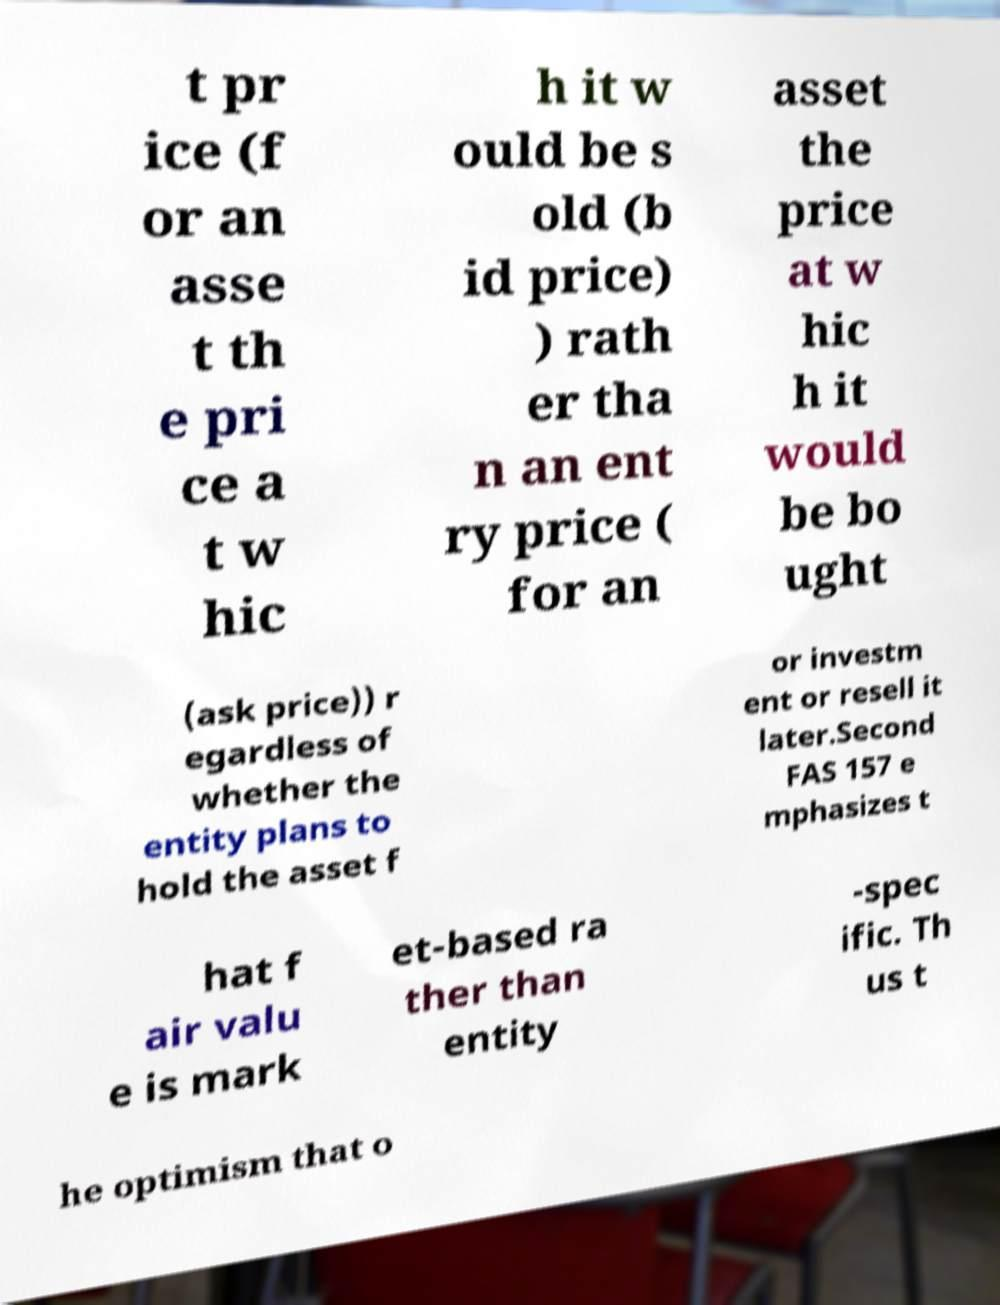I need the written content from this picture converted into text. Can you do that? t pr ice (f or an asse t th e pri ce a t w hic h it w ould be s old (b id price) ) rath er tha n an ent ry price ( for an asset the price at w hic h it would be bo ught (ask price)) r egardless of whether the entity plans to hold the asset f or investm ent or resell it later.Second FAS 157 e mphasizes t hat f air valu e is mark et-based ra ther than entity -spec ific. Th us t he optimism that o 